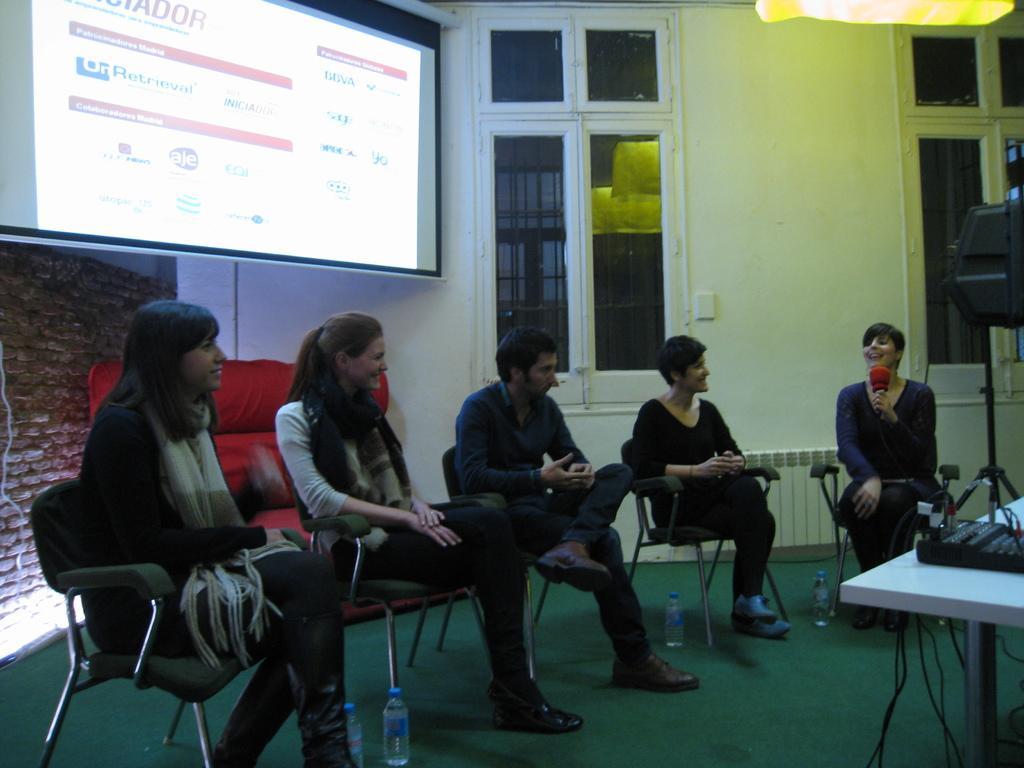How would you summarize this image in a sentence or two? In this picture we can see five people sitting on chairs one man and four women, the woman on the right side is holding mic and she is smiling, on the left side of the image we can see a projector screen and, in the bottom we can see a brick wall, in the background we can see a wall and glass window, on the right side of the image we can you see a table, in the bottom there are some of the bottles here. 